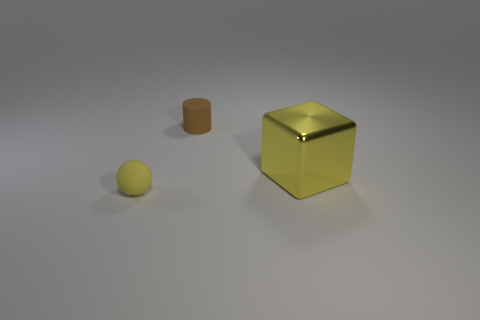Add 2 gray spheres. How many objects exist? 5 Subtract all blocks. How many objects are left? 2 Add 2 small brown things. How many small brown things are left? 3 Add 3 small brown matte cylinders. How many small brown matte cylinders exist? 4 Subtract 1 brown cylinders. How many objects are left? 2 Subtract all cyan metal balls. Subtract all small brown matte things. How many objects are left? 2 